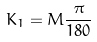Convert formula to latex. <formula><loc_0><loc_0><loc_500><loc_500>K _ { 1 } = M \frac { \pi } { 1 8 0 }</formula> 